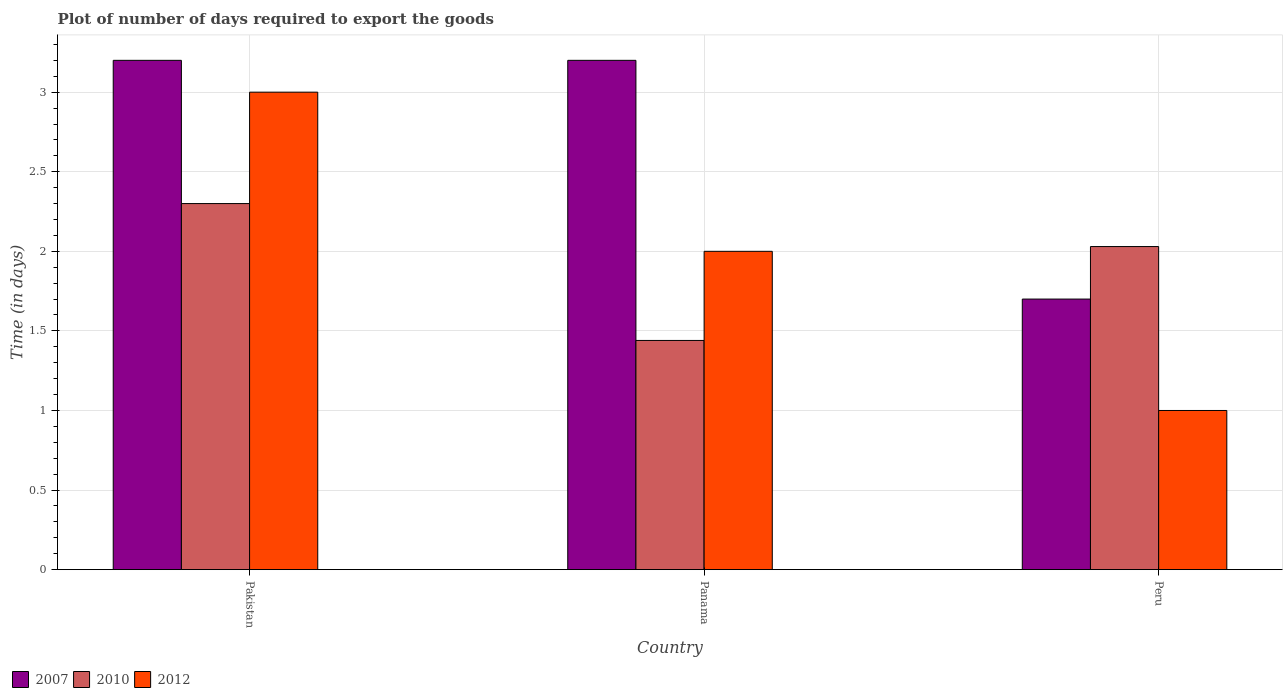How many groups of bars are there?
Provide a short and direct response. 3. In which country was the time required to export goods in 2010 maximum?
Give a very brief answer. Pakistan. In which country was the time required to export goods in 2010 minimum?
Your answer should be very brief. Panama. What is the total time required to export goods in 2010 in the graph?
Offer a very short reply. 5.77. What is the difference between the time required to export goods in 2007 in Peru and the time required to export goods in 2010 in Pakistan?
Keep it short and to the point. -0.6. What is the average time required to export goods in 2012 per country?
Provide a succinct answer. 2. What is the difference between the time required to export goods of/in 2007 and time required to export goods of/in 2010 in Pakistan?
Your response must be concise. 0.9. What is the ratio of the time required to export goods in 2010 in Pakistan to that in Panama?
Make the answer very short. 1.6. What is the difference between the highest and the second highest time required to export goods in 2012?
Keep it short and to the point. -1. What is the difference between the highest and the lowest time required to export goods in 2012?
Make the answer very short. 2. In how many countries, is the time required to export goods in 2012 greater than the average time required to export goods in 2012 taken over all countries?
Offer a very short reply. 1. Is the sum of the time required to export goods in 2010 in Pakistan and Panama greater than the maximum time required to export goods in 2012 across all countries?
Provide a short and direct response. Yes. What does the 1st bar from the left in Pakistan represents?
Provide a succinct answer. 2007. Is it the case that in every country, the sum of the time required to export goods in 2007 and time required to export goods in 2012 is greater than the time required to export goods in 2010?
Your answer should be compact. Yes. Are all the bars in the graph horizontal?
Your response must be concise. No. What is the difference between two consecutive major ticks on the Y-axis?
Keep it short and to the point. 0.5. Does the graph contain any zero values?
Offer a terse response. No. Where does the legend appear in the graph?
Give a very brief answer. Bottom left. How many legend labels are there?
Make the answer very short. 3. What is the title of the graph?
Keep it short and to the point. Plot of number of days required to export the goods. What is the label or title of the Y-axis?
Your answer should be very brief. Time (in days). What is the Time (in days) of 2007 in Pakistan?
Offer a very short reply. 3.2. What is the Time (in days) of 2010 in Pakistan?
Make the answer very short. 2.3. What is the Time (in days) of 2012 in Pakistan?
Ensure brevity in your answer.  3. What is the Time (in days) of 2010 in Panama?
Provide a short and direct response. 1.44. What is the Time (in days) in 2012 in Panama?
Offer a very short reply. 2. What is the Time (in days) in 2007 in Peru?
Your response must be concise. 1.7. What is the Time (in days) of 2010 in Peru?
Offer a very short reply. 2.03. Across all countries, what is the maximum Time (in days) of 2007?
Provide a short and direct response. 3.2. Across all countries, what is the minimum Time (in days) in 2010?
Provide a succinct answer. 1.44. Across all countries, what is the minimum Time (in days) in 2012?
Your response must be concise. 1. What is the total Time (in days) in 2007 in the graph?
Your answer should be compact. 8.1. What is the total Time (in days) in 2010 in the graph?
Make the answer very short. 5.77. What is the difference between the Time (in days) of 2007 in Pakistan and that in Panama?
Make the answer very short. 0. What is the difference between the Time (in days) in 2010 in Pakistan and that in Panama?
Your answer should be compact. 0.86. What is the difference between the Time (in days) of 2012 in Pakistan and that in Panama?
Keep it short and to the point. 1. What is the difference between the Time (in days) of 2007 in Pakistan and that in Peru?
Your answer should be very brief. 1.5. What is the difference between the Time (in days) of 2010 in Pakistan and that in Peru?
Offer a terse response. 0.27. What is the difference between the Time (in days) in 2012 in Pakistan and that in Peru?
Offer a very short reply. 2. What is the difference between the Time (in days) in 2007 in Panama and that in Peru?
Offer a terse response. 1.5. What is the difference between the Time (in days) in 2010 in Panama and that in Peru?
Offer a terse response. -0.59. What is the difference between the Time (in days) of 2012 in Panama and that in Peru?
Offer a terse response. 1. What is the difference between the Time (in days) in 2007 in Pakistan and the Time (in days) in 2010 in Panama?
Make the answer very short. 1.76. What is the difference between the Time (in days) of 2007 in Pakistan and the Time (in days) of 2010 in Peru?
Keep it short and to the point. 1.17. What is the difference between the Time (in days) of 2010 in Pakistan and the Time (in days) of 2012 in Peru?
Provide a succinct answer. 1.3. What is the difference between the Time (in days) in 2007 in Panama and the Time (in days) in 2010 in Peru?
Your answer should be compact. 1.17. What is the difference between the Time (in days) in 2007 in Panama and the Time (in days) in 2012 in Peru?
Your answer should be very brief. 2.2. What is the difference between the Time (in days) of 2010 in Panama and the Time (in days) of 2012 in Peru?
Ensure brevity in your answer.  0.44. What is the average Time (in days) in 2010 per country?
Provide a short and direct response. 1.92. What is the average Time (in days) of 2012 per country?
Your answer should be compact. 2. What is the difference between the Time (in days) in 2007 and Time (in days) in 2010 in Pakistan?
Offer a terse response. 0.9. What is the difference between the Time (in days) of 2007 and Time (in days) of 2012 in Pakistan?
Provide a succinct answer. 0.2. What is the difference between the Time (in days) in 2010 and Time (in days) in 2012 in Pakistan?
Your answer should be compact. -0.7. What is the difference between the Time (in days) of 2007 and Time (in days) of 2010 in Panama?
Your answer should be very brief. 1.76. What is the difference between the Time (in days) of 2007 and Time (in days) of 2012 in Panama?
Provide a short and direct response. 1.2. What is the difference between the Time (in days) of 2010 and Time (in days) of 2012 in Panama?
Give a very brief answer. -0.56. What is the difference between the Time (in days) of 2007 and Time (in days) of 2010 in Peru?
Offer a very short reply. -0.33. What is the difference between the Time (in days) of 2010 and Time (in days) of 2012 in Peru?
Offer a terse response. 1.03. What is the ratio of the Time (in days) in 2007 in Pakistan to that in Panama?
Keep it short and to the point. 1. What is the ratio of the Time (in days) in 2010 in Pakistan to that in Panama?
Your answer should be compact. 1.6. What is the ratio of the Time (in days) in 2007 in Pakistan to that in Peru?
Your answer should be very brief. 1.88. What is the ratio of the Time (in days) in 2010 in Pakistan to that in Peru?
Keep it short and to the point. 1.13. What is the ratio of the Time (in days) in 2007 in Panama to that in Peru?
Provide a succinct answer. 1.88. What is the ratio of the Time (in days) in 2010 in Panama to that in Peru?
Your response must be concise. 0.71. What is the difference between the highest and the second highest Time (in days) in 2007?
Your answer should be compact. 0. What is the difference between the highest and the second highest Time (in days) in 2010?
Your answer should be very brief. 0.27. What is the difference between the highest and the lowest Time (in days) in 2010?
Offer a terse response. 0.86. 